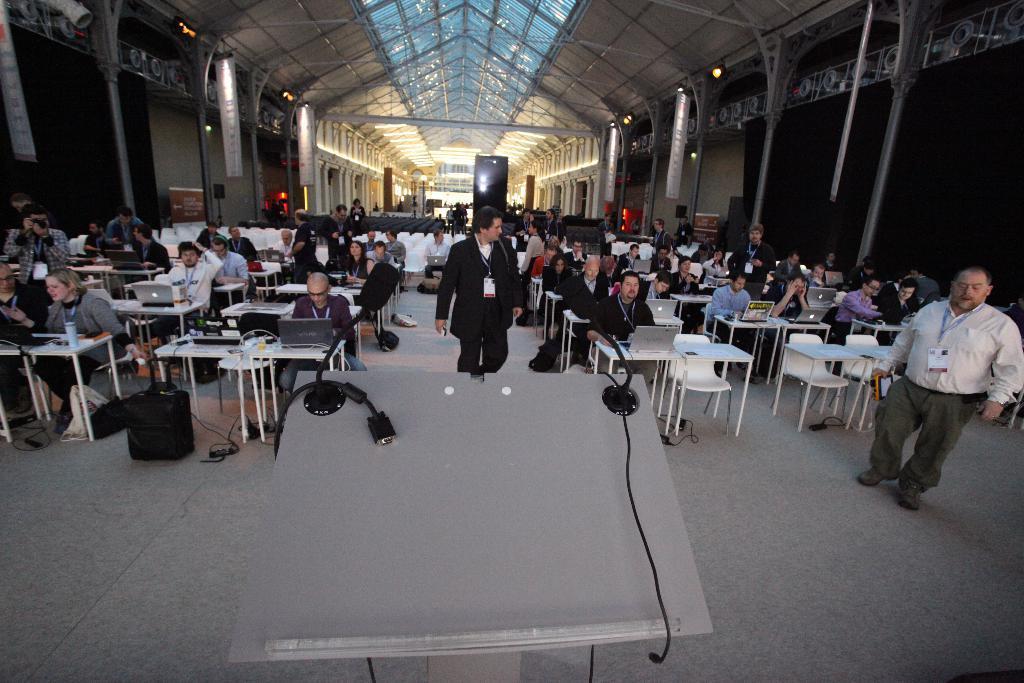Could you give a brief overview of what you see in this image? In this image we can see many people sitting on chairs. Some are standing and they are wearing tags. Also there are tables with laptops and there are many other items. In the back we can see lights. Also we can see pillars. 